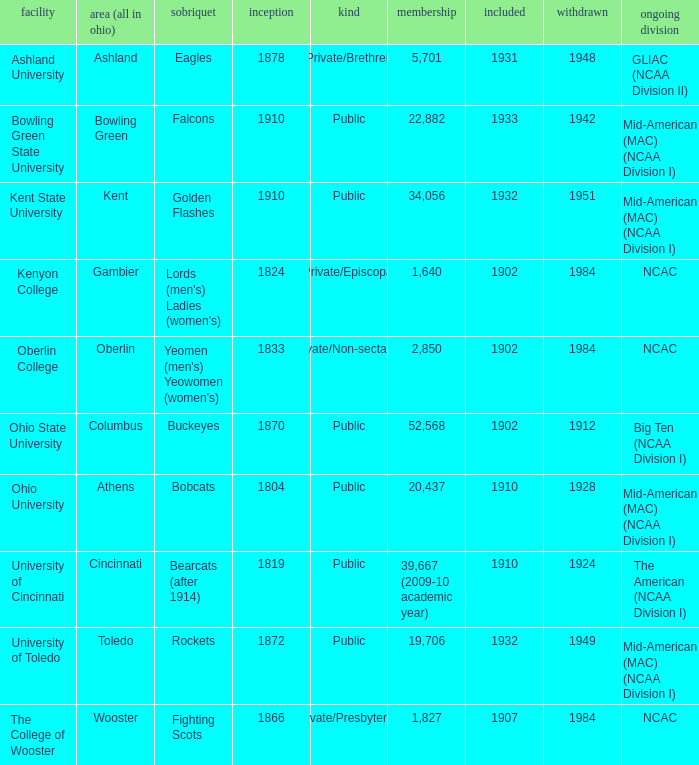Which founding year corresponds with the highest enrollment?  1910.0. 